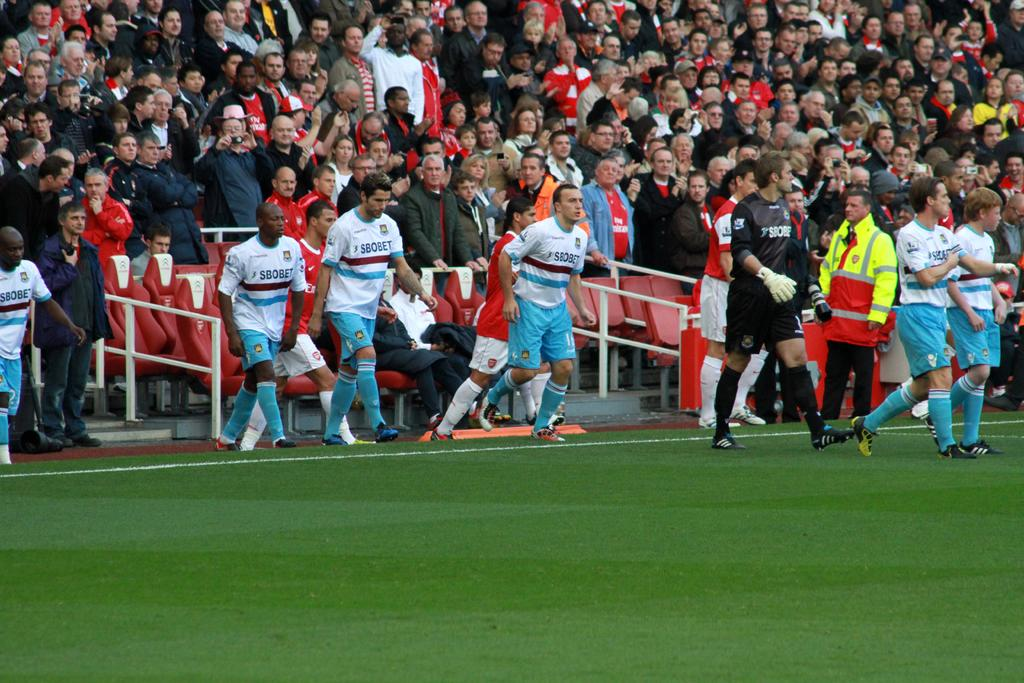What is the setting of the image? The setting of the image is a grass field where people are standing. What can be seen in the background of the image? In the background, there is a group of audience and chairs. There are also barricades present. What might the people on the grass field be doing? It is not clear from the image what the people on the grass field are doing, but they could be participating in an event or gathering. What type of food is being served on a cord in the image? There is no food or cord present in the image. Can you see a snail crawling on the grass field in the image? There is no snail visible in the image. 